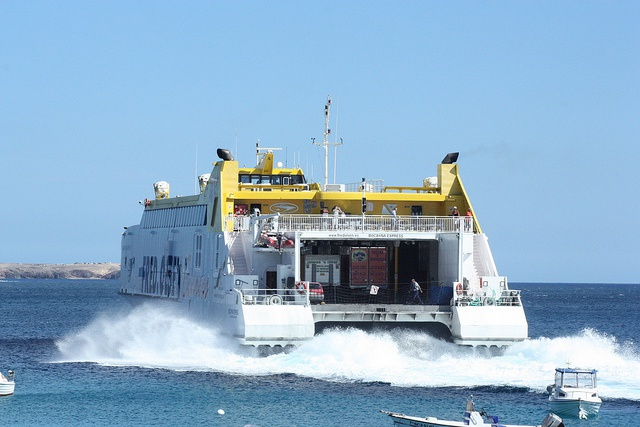Describe the objects in this image and their specific colors. I can see boat in lightblue, white, black, gray, and darkgray tones, boat in lightblue, white, blue, and gray tones, boat in lightblue, white, gray, and darkgray tones, people in lightblue, black, gray, and darkgray tones, and people in lightblue, lightgray, darkgray, gray, and black tones in this image. 